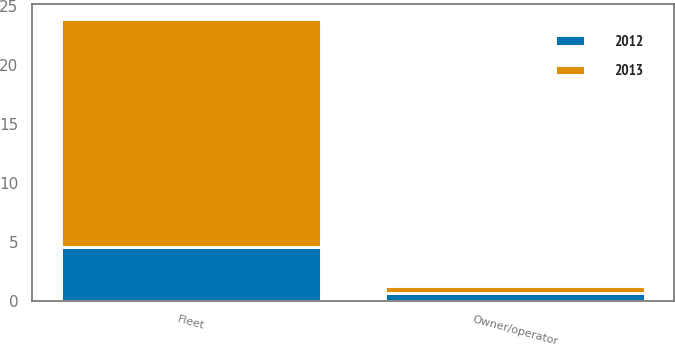<chart> <loc_0><loc_0><loc_500><loc_500><stacked_bar_chart><ecel><fcel>Fleet<fcel>Owner/operator<nl><fcel>2012<fcel>4.6<fcel>0.7<nl><fcel>2013<fcel>19.3<fcel>0.6<nl></chart> 